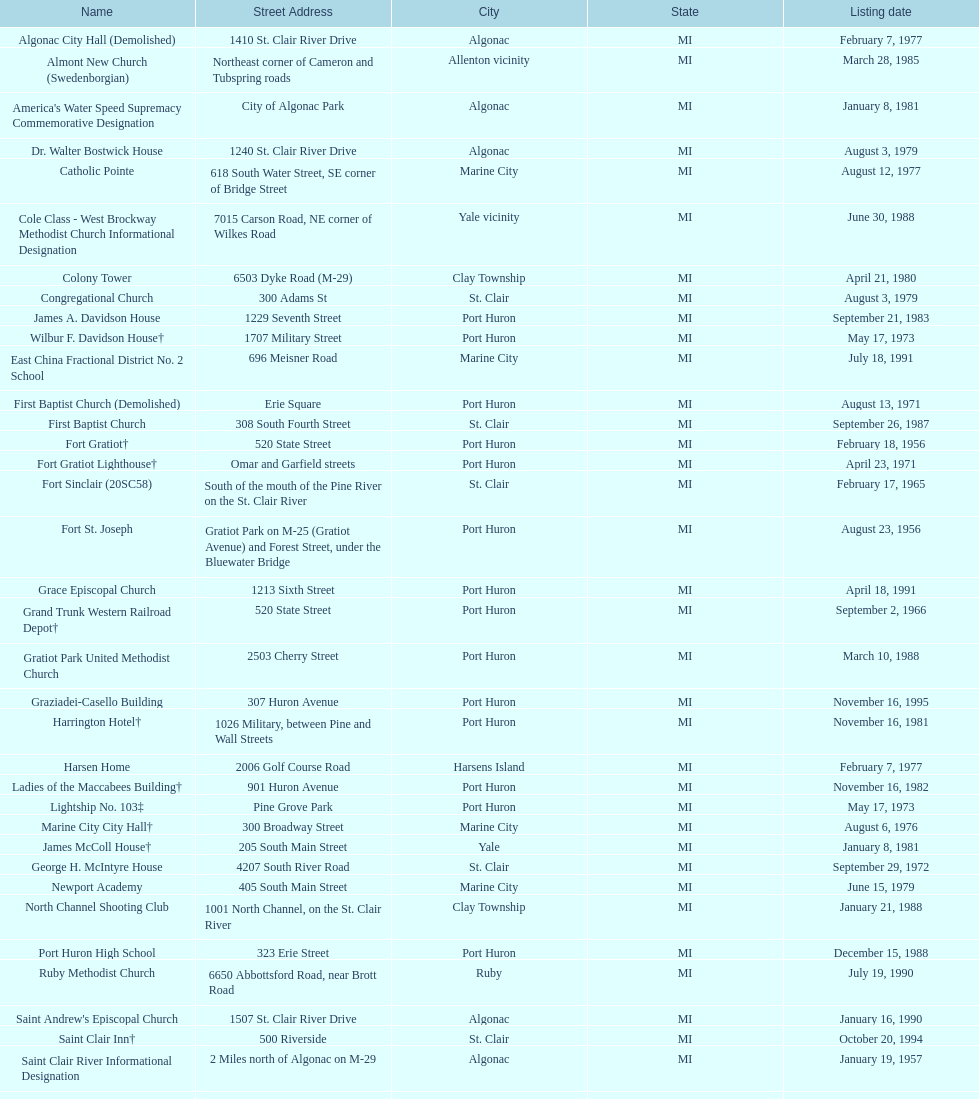Fort gratiot lighthouse and fort st. joseph are located in what city? Port Huron. 